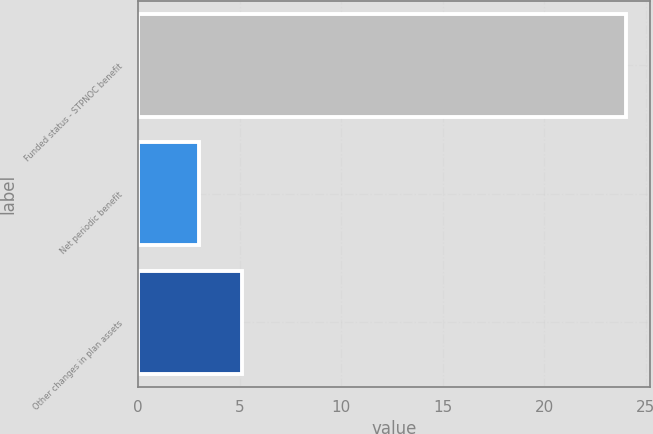<chart> <loc_0><loc_0><loc_500><loc_500><bar_chart><fcel>Funded status - STPNOC benefit<fcel>Net periodic benefit<fcel>Other changes in plan assets<nl><fcel>24<fcel>3<fcel>5.1<nl></chart> 